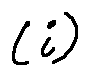Convert formula to latex. <formula><loc_0><loc_0><loc_500><loc_500>( i )</formula> 